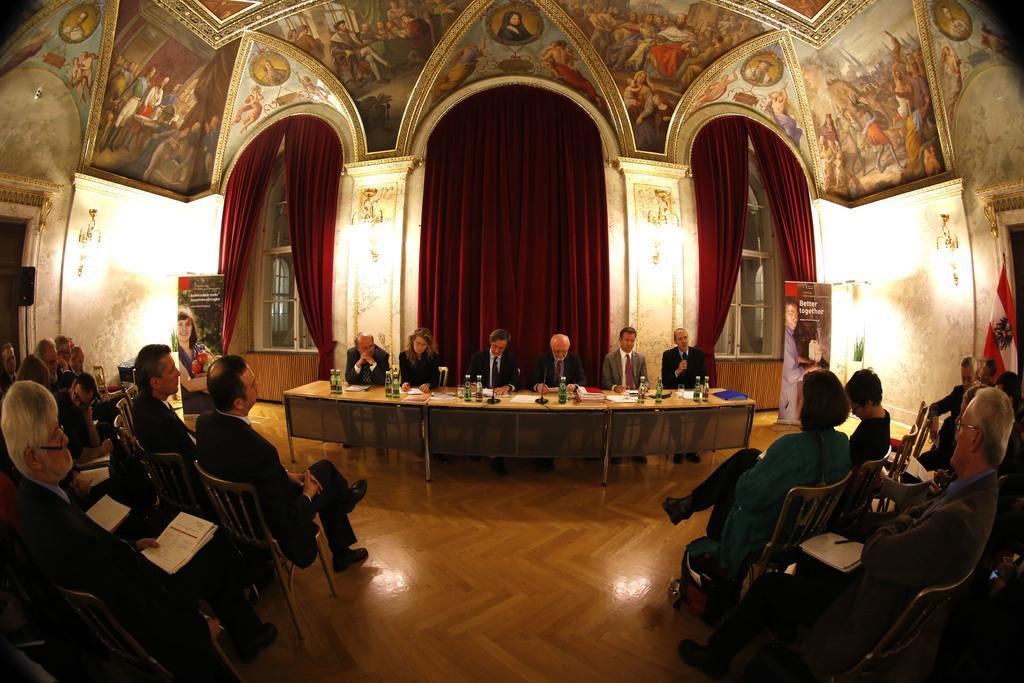Could you give a brief overview of what you see in this image? In this image I can see a conference hall where people are sitting in chairs in the left bottom and right bottom corners. I can see a table with some water bottles, papers, a mike and other objects on it. I can see a few people sitting chairs behind the table. I can see some lights on the wall. I can see a flag, banners with some text. images, curtains and a colorful rooftop.  